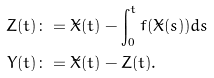Convert formula to latex. <formula><loc_0><loc_0><loc_500><loc_500>Z ( t ) & \colon = \tilde { X } ( t ) - \int _ { 0 } ^ { t } f ( \tilde { X } ( s ) ) d s \\ Y ( t ) & \colon = \tilde { X } ( t ) - Z ( t ) .</formula> 